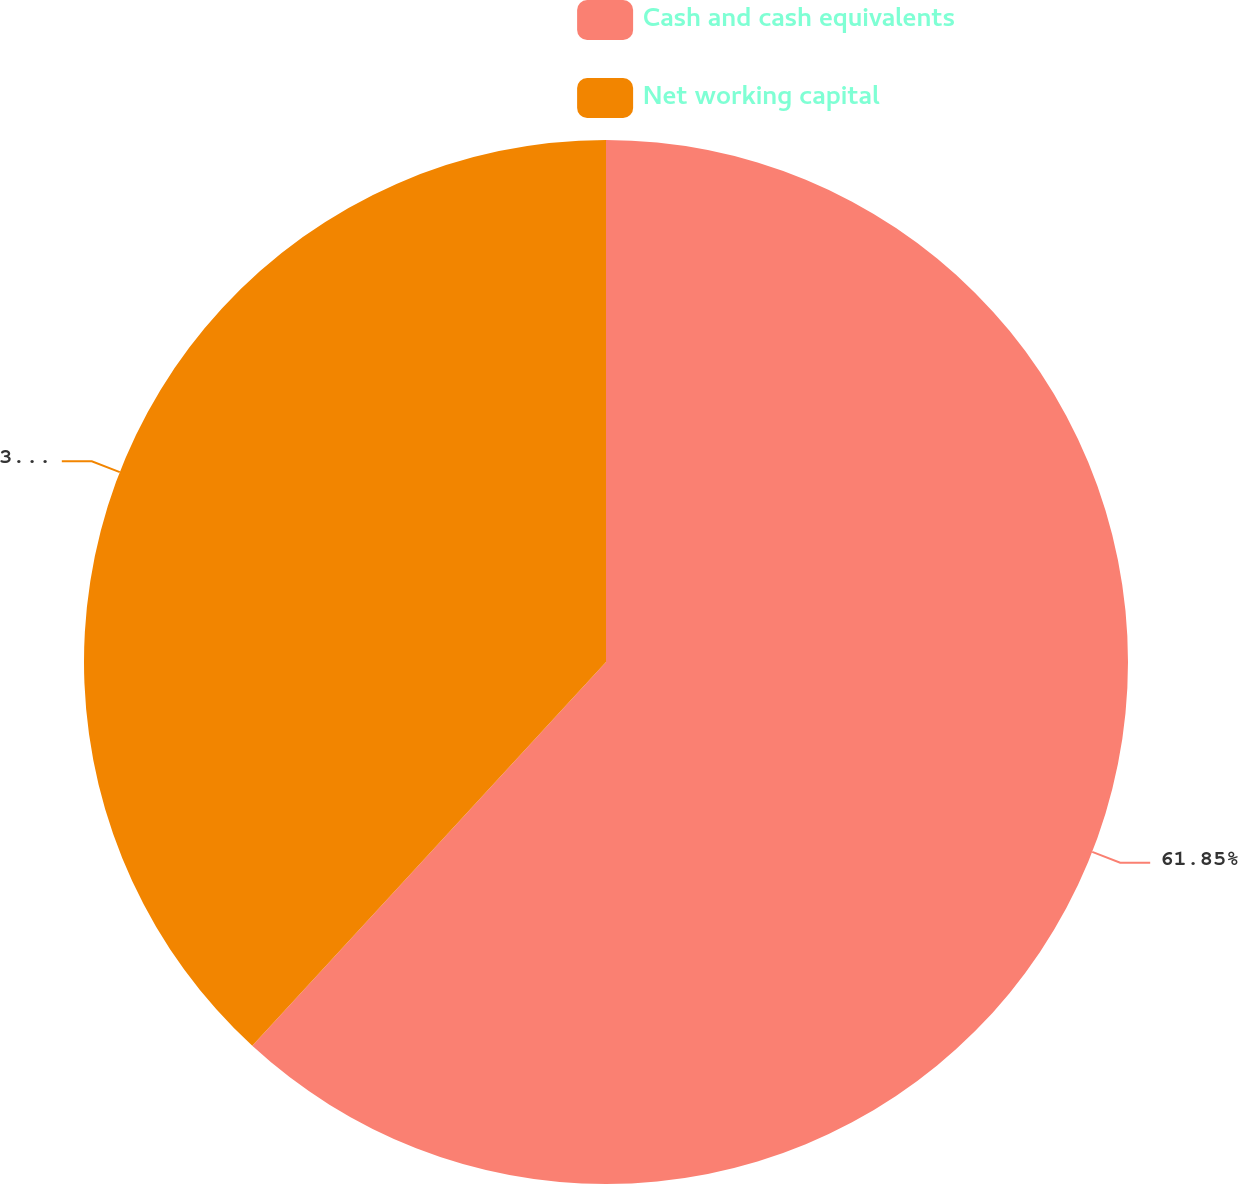Convert chart to OTSL. <chart><loc_0><loc_0><loc_500><loc_500><pie_chart><fcel>Cash and cash equivalents<fcel>Net working capital<nl><fcel>61.85%<fcel>38.15%<nl></chart> 